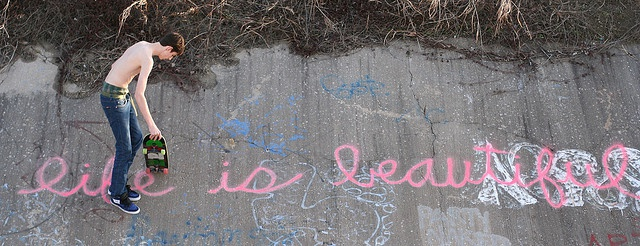Describe the objects in this image and their specific colors. I can see people in gray, navy, lightgray, black, and pink tones and skateboard in gray, black, darkgreen, and darkgray tones in this image. 